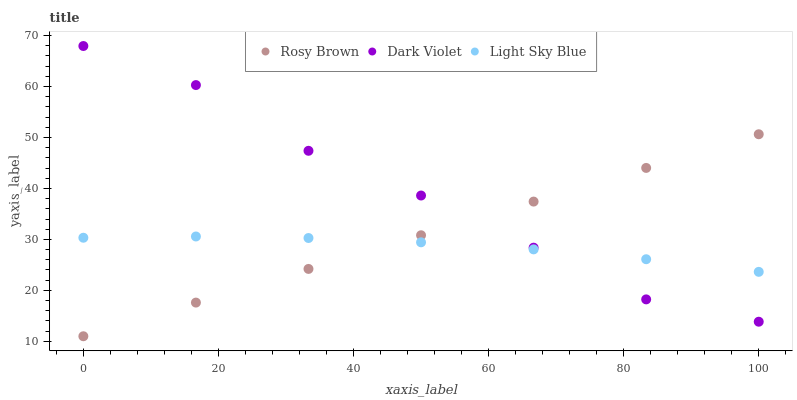Does Light Sky Blue have the minimum area under the curve?
Answer yes or no. Yes. Does Dark Violet have the maximum area under the curve?
Answer yes or no. Yes. Does Dark Violet have the minimum area under the curve?
Answer yes or no. No. Does Light Sky Blue have the maximum area under the curve?
Answer yes or no. No. Is Rosy Brown the smoothest?
Answer yes or no. Yes. Is Dark Violet the roughest?
Answer yes or no. Yes. Is Light Sky Blue the smoothest?
Answer yes or no. No. Is Light Sky Blue the roughest?
Answer yes or no. No. Does Rosy Brown have the lowest value?
Answer yes or no. Yes. Does Dark Violet have the lowest value?
Answer yes or no. No. Does Dark Violet have the highest value?
Answer yes or no. Yes. Does Light Sky Blue have the highest value?
Answer yes or no. No. Does Rosy Brown intersect Light Sky Blue?
Answer yes or no. Yes. Is Rosy Brown less than Light Sky Blue?
Answer yes or no. No. Is Rosy Brown greater than Light Sky Blue?
Answer yes or no. No. 